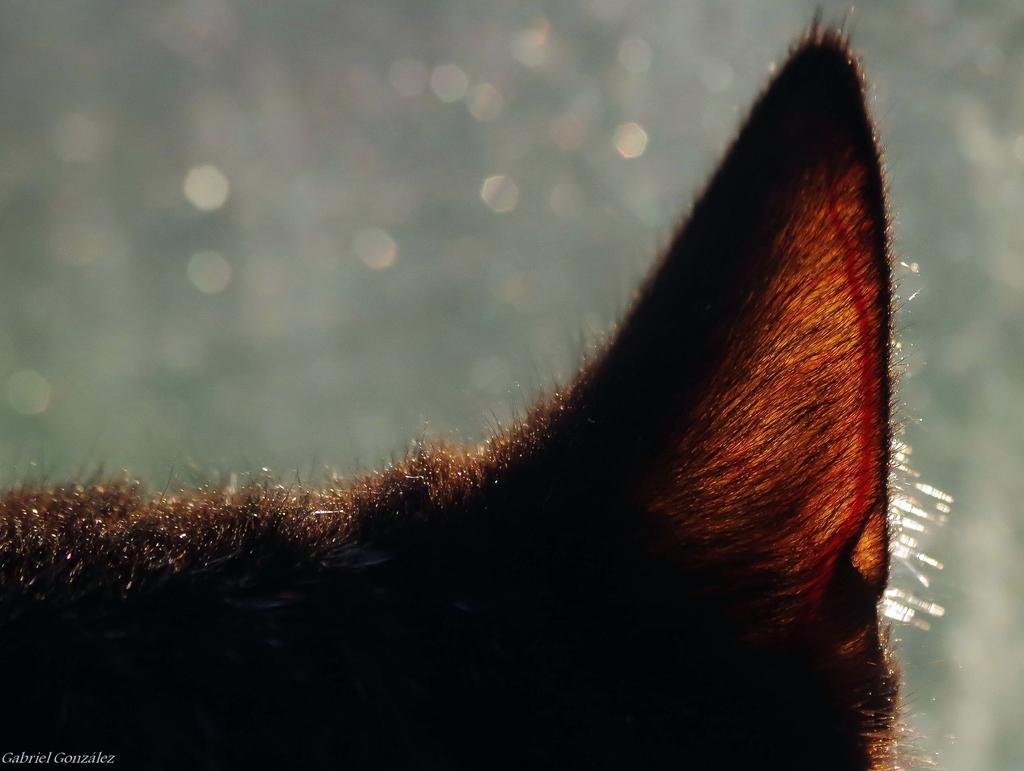Could you give a brief overview of what you see in this image? In this image, we can see the ear of an animal. We can also see the blurred background and some text on the bottom left corner. 